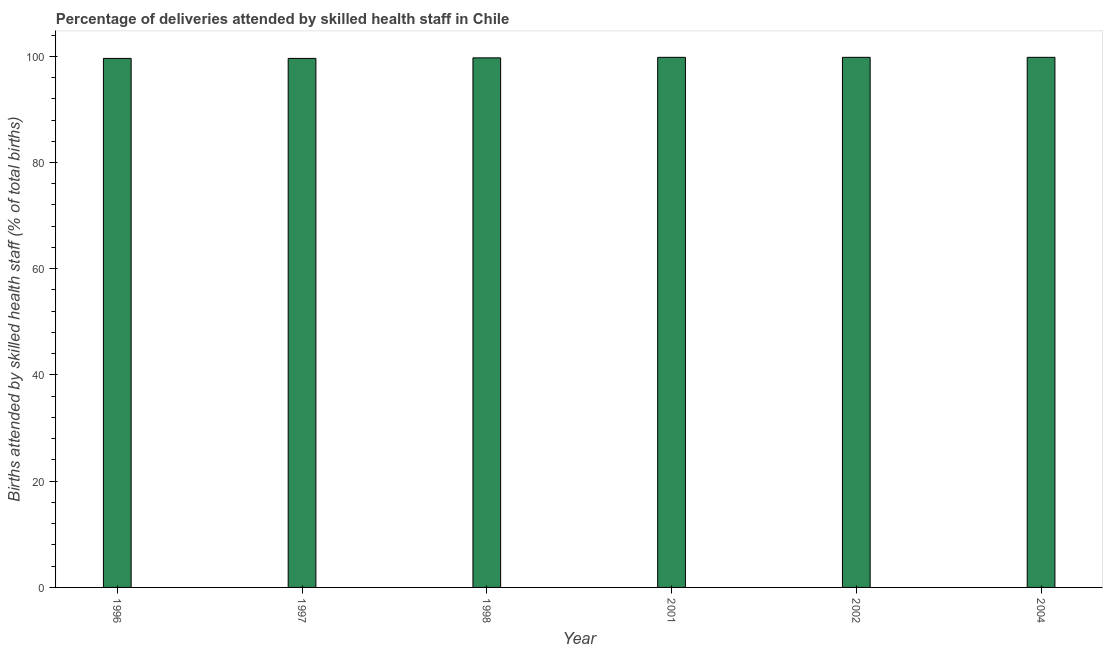Does the graph contain any zero values?
Ensure brevity in your answer.  No. What is the title of the graph?
Make the answer very short. Percentage of deliveries attended by skilled health staff in Chile. What is the label or title of the X-axis?
Offer a very short reply. Year. What is the label or title of the Y-axis?
Make the answer very short. Births attended by skilled health staff (% of total births). What is the number of births attended by skilled health staff in 1998?
Provide a short and direct response. 99.7. Across all years, what is the maximum number of births attended by skilled health staff?
Offer a terse response. 99.8. Across all years, what is the minimum number of births attended by skilled health staff?
Your answer should be very brief. 99.6. In which year was the number of births attended by skilled health staff maximum?
Your response must be concise. 2001. In which year was the number of births attended by skilled health staff minimum?
Ensure brevity in your answer.  1996. What is the sum of the number of births attended by skilled health staff?
Give a very brief answer. 598.3. What is the difference between the number of births attended by skilled health staff in 1996 and 1998?
Keep it short and to the point. -0.1. What is the average number of births attended by skilled health staff per year?
Keep it short and to the point. 99.72. What is the median number of births attended by skilled health staff?
Ensure brevity in your answer.  99.75. In how many years, is the number of births attended by skilled health staff greater than 36 %?
Your answer should be compact. 6. Do a majority of the years between 1997 and 1996 (inclusive) have number of births attended by skilled health staff greater than 4 %?
Offer a terse response. No. What is the difference between the highest and the lowest number of births attended by skilled health staff?
Offer a terse response. 0.2. In how many years, is the number of births attended by skilled health staff greater than the average number of births attended by skilled health staff taken over all years?
Offer a very short reply. 3. How many bars are there?
Give a very brief answer. 6. Are all the bars in the graph horizontal?
Your answer should be very brief. No. How many years are there in the graph?
Your answer should be very brief. 6. What is the Births attended by skilled health staff (% of total births) in 1996?
Your answer should be compact. 99.6. What is the Births attended by skilled health staff (% of total births) of 1997?
Your answer should be compact. 99.6. What is the Births attended by skilled health staff (% of total births) of 1998?
Your answer should be very brief. 99.7. What is the Births attended by skilled health staff (% of total births) of 2001?
Your answer should be compact. 99.8. What is the Births attended by skilled health staff (% of total births) in 2002?
Your answer should be compact. 99.8. What is the Births attended by skilled health staff (% of total births) in 2004?
Provide a succinct answer. 99.8. What is the difference between the Births attended by skilled health staff (% of total births) in 1996 and 1998?
Offer a very short reply. -0.1. What is the difference between the Births attended by skilled health staff (% of total births) in 1996 and 2001?
Offer a very short reply. -0.2. What is the difference between the Births attended by skilled health staff (% of total births) in 1996 and 2002?
Give a very brief answer. -0.2. What is the difference between the Births attended by skilled health staff (% of total births) in 1997 and 1998?
Your answer should be compact. -0.1. What is the difference between the Births attended by skilled health staff (% of total births) in 1997 and 2001?
Offer a terse response. -0.2. What is the difference between the Births attended by skilled health staff (% of total births) in 1997 and 2002?
Your response must be concise. -0.2. What is the difference between the Births attended by skilled health staff (% of total births) in 1998 and 2001?
Your answer should be compact. -0.1. What is the difference between the Births attended by skilled health staff (% of total births) in 2001 and 2002?
Offer a terse response. 0. What is the ratio of the Births attended by skilled health staff (% of total births) in 1996 to that in 2002?
Offer a terse response. 1. What is the ratio of the Births attended by skilled health staff (% of total births) in 1996 to that in 2004?
Your response must be concise. 1. What is the ratio of the Births attended by skilled health staff (% of total births) in 1997 to that in 2001?
Your answer should be very brief. 1. What is the ratio of the Births attended by skilled health staff (% of total births) in 1997 to that in 2002?
Your response must be concise. 1. What is the ratio of the Births attended by skilled health staff (% of total births) in 1997 to that in 2004?
Your response must be concise. 1. What is the ratio of the Births attended by skilled health staff (% of total births) in 1998 to that in 2001?
Keep it short and to the point. 1. What is the ratio of the Births attended by skilled health staff (% of total births) in 2001 to that in 2002?
Your answer should be compact. 1. What is the ratio of the Births attended by skilled health staff (% of total births) in 2001 to that in 2004?
Offer a terse response. 1. 